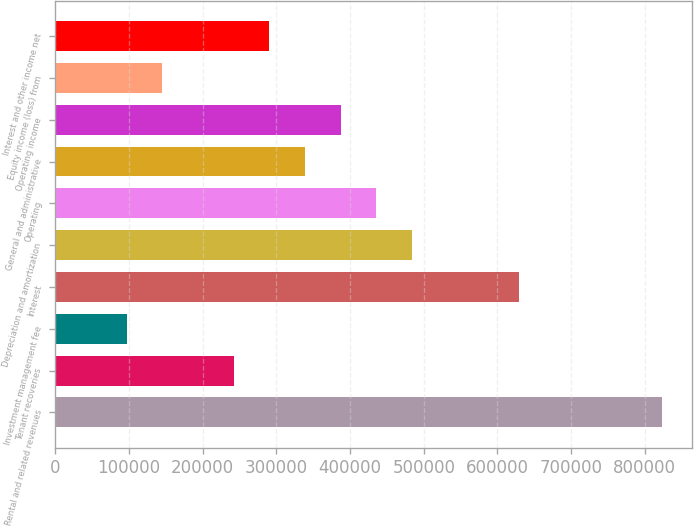<chart> <loc_0><loc_0><loc_500><loc_500><bar_chart><fcel>Rental and related revenues<fcel>Tenant recoveries<fcel>Investment management fee<fcel>Interest<fcel>Depreciation and amortization<fcel>Operating<fcel>General and administrative<fcel>Operating income<fcel>Equity income (loss) from<fcel>Interest and other income net<nl><fcel>822665<fcel>241961<fcel>96784.5<fcel>629097<fcel>483921<fcel>435529<fcel>338745<fcel>387137<fcel>145177<fcel>290353<nl></chart> 